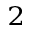Convert formula to latex. <formula><loc_0><loc_0><loc_500><loc_500>^ { 2 }</formula> 